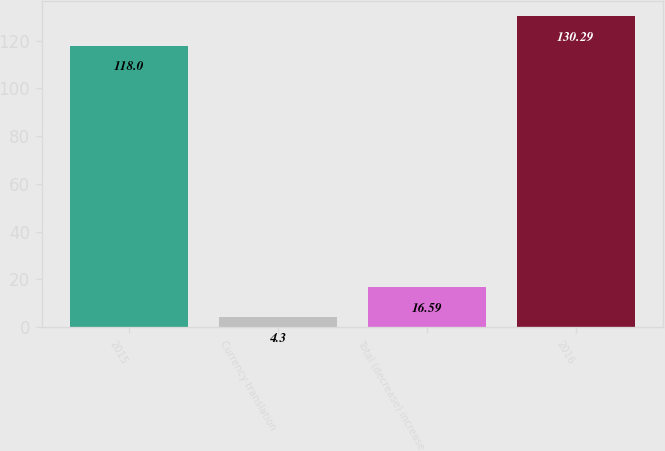<chart> <loc_0><loc_0><loc_500><loc_500><bar_chart><fcel>2015<fcel>Currency translation<fcel>Total (decrease) increase<fcel>2016<nl><fcel>118<fcel>4.3<fcel>16.59<fcel>130.29<nl></chart> 